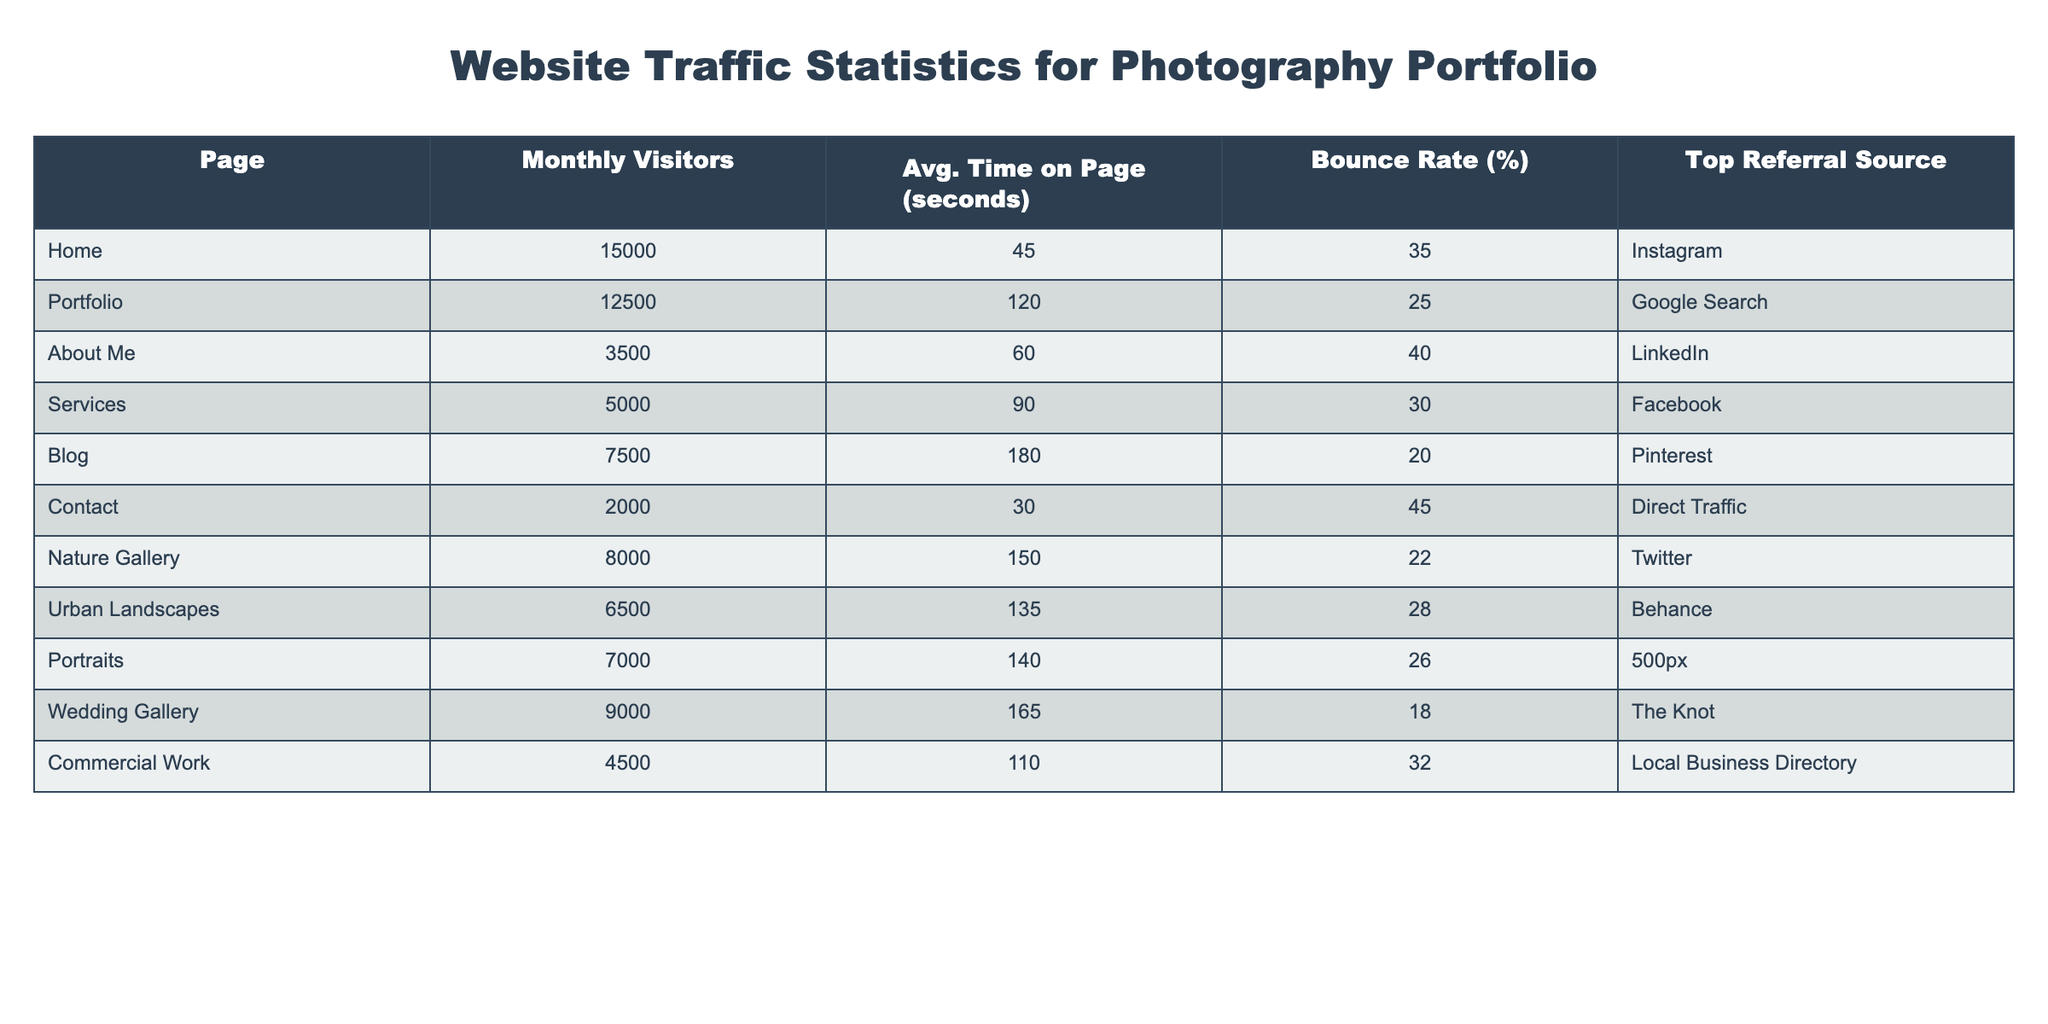What's the page with the highest monthly visitors? By examining the "Monthly Visitors" column, we can see that the "Home" page has the highest number of visitors at 15,000.
Answer: Home What is the average time on the "Portfolio" page? The "Avg. Time on Page (seconds)" for the "Portfolio" page is directly listed in the table as 120 seconds.
Answer: 120 seconds Which page has the lowest bounce rate? The "Bounce Rate (%)" column indicates that the "Wedding Gallery" has the lowest bounce rate at 18%.
Answer: Wedding Gallery How many more visitors does the "Blog" page have compared to the "Contact" page? The "Blog" page has 7,500 visitors and the "Contact" page has 2,000 visitors. The difference is 7,500 - 2,000 = 5,500.
Answer: 5,500 visitors What is the total number of monthly visitors for all pages listed? To find the total, we sum the visitors: 15,000 + 12,500 + 3,500 + 5,000 + 7,500 + 2,000 + 8,000 + 6,500 + 7,000 + 9,000 + 4,500 = 78,500.
Answer: 78,500 Which referral source is most common for the pages listed? By checking the "Top Referral Source", "Instagram" refers users to the "Home" page, while other sources refer to one respective page. As such, "Instagram" is the only one mentioned more than once, making it the most common source here.
Answer: Instagram Is the average time on the "Nature Gallery" page more than 150 seconds? The "Avg. Time on Page (seconds)" for the "Nature Gallery" is listed as 150 seconds, therefore it is not greater than 150 seconds.
Answer: No What is the combined average time on page for the "Nature Gallery" and "Wedding Gallery"? The average time for "Nature Gallery" is 150 seconds and for "Wedding Gallery" it is 165 seconds. Summing these gives 150 + 165 = 315 seconds; the average is 315/2 = 157.5 seconds.
Answer: 157.5 seconds Which page has the highest average time on page and what is that time? By checking the "Avg. Time on Page (seconds)", the "Blog" page has the highest time at 180 seconds.
Answer: Blog, 180 seconds Is there any page with a bounce rate lower than 20%? The "Bounce Rate (%)" column indicates that "Blog" has a bounce rate of 20%, meaning there is no page below 20%.
Answer: No 